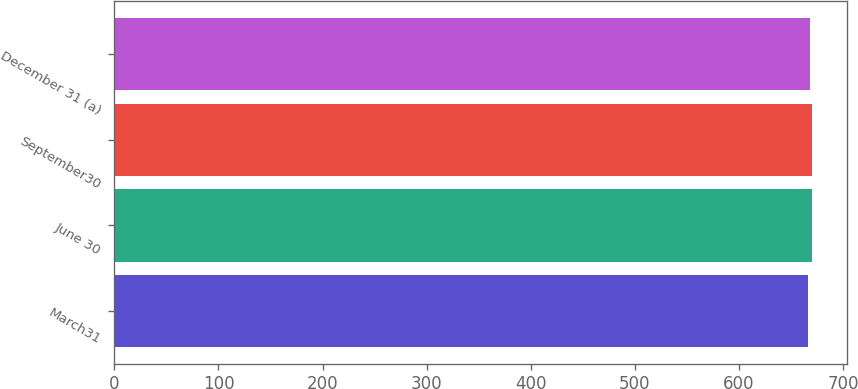Convert chart to OTSL. <chart><loc_0><loc_0><loc_500><loc_500><bar_chart><fcel>March31<fcel>June 30<fcel>September30<fcel>December 31 (a)<nl><fcel>666<fcel>670<fcel>670.4<fcel>668<nl></chart> 